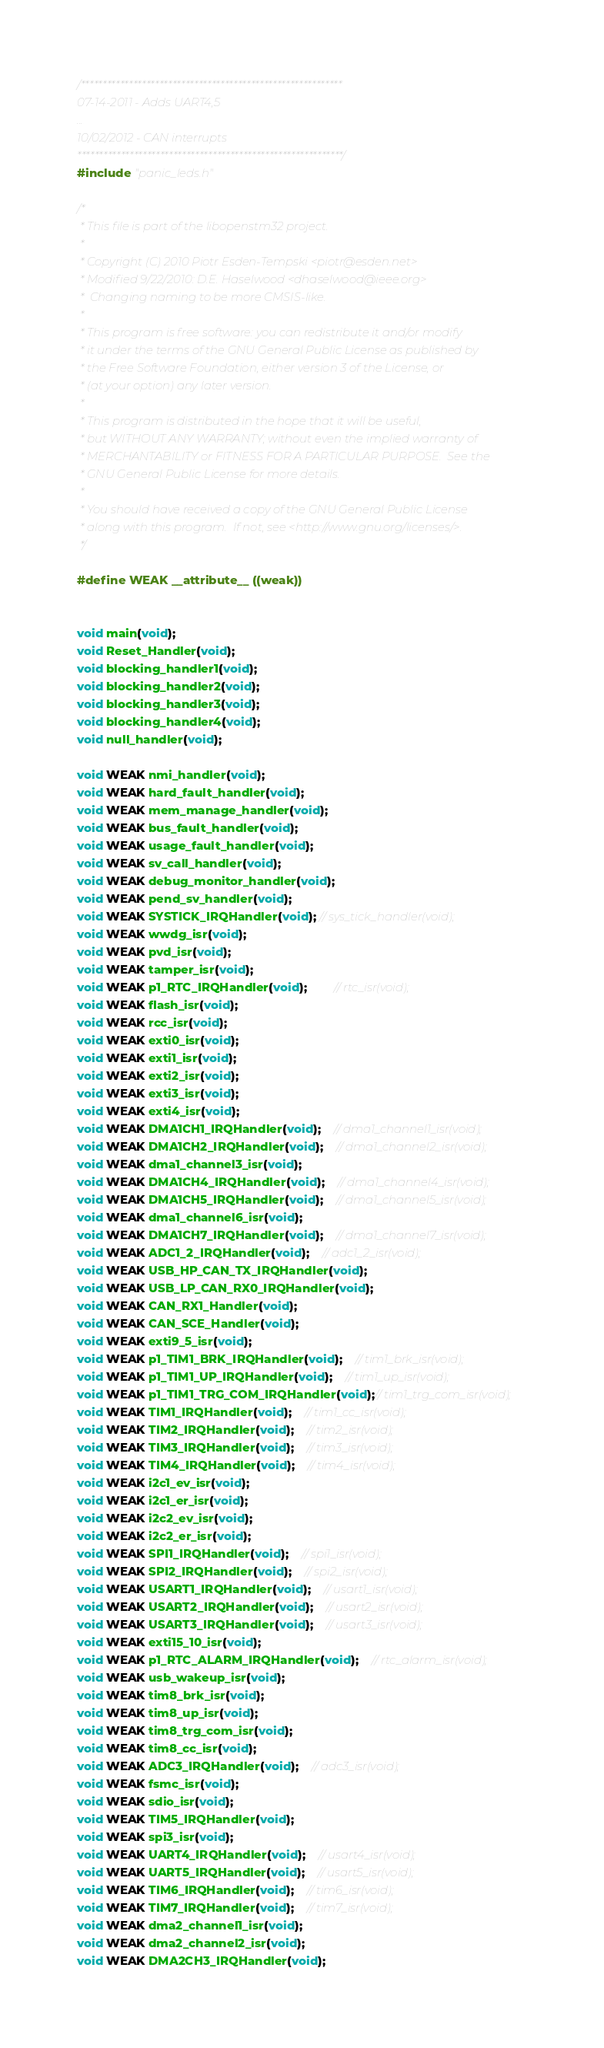Convert code to text. <code><loc_0><loc_0><loc_500><loc_500><_C_>/************************************************************
07-14-2011 - Adds UART4,5
...
10/02/2012 - CAN interrupts
*************************************************************/
#include "panic_leds.h"

/*
 * This file is part of the libopenstm32 project.
 *
 * Copyright (C) 2010 Piotr Esden-Tempski <piotr@esden.net>
 * Modified 9/22/2010: D.E. Haselwood <dhaselwood@ieee.org>
 *  Changing naming to be more CMSIS-like.
 *
 * This program is free software: you can redistribute it and/or modify
 * it under the terms of the GNU General Public License as published by
 * the Free Software Foundation, either version 3 of the License, or
 * (at your option) any later version.
 *
 * This program is distributed in the hope that it will be useful,
 * but WITHOUT ANY WARRANTY; without even the implied warranty of
 * MERCHANTABILITY or FITNESS FOR A PARTICULAR PURPOSE.  See the
 * GNU General Public License for more details.
 *
 * You should have received a copy of the GNU General Public License
 * along with this program.  If not, see <http://www.gnu.org/licenses/>.
 */

#define WEAK __attribute__ ((weak))


void main(void);
void Reset_Handler(void);
void blocking_handler1(void);
void blocking_handler2(void);
void blocking_handler3(void);
void blocking_handler4(void);
void null_handler(void);

void WEAK nmi_handler(void);
void WEAK hard_fault_handler(void);
void WEAK mem_manage_handler(void);
void WEAK bus_fault_handler(void);
void WEAK usage_fault_handler(void);
void WEAK sv_call_handler(void);
void WEAK debug_monitor_handler(void);
void WEAK pend_sv_handler(void);
void WEAK SYSTICK_IRQHandler(void); // sys_tick_handler(void);
void WEAK wwdg_isr(void);
void WEAK pvd_isr(void);
void WEAK tamper_isr(void);
void WEAK p1_RTC_IRQHandler(void);	    // rtc_isr(void);
void WEAK flash_isr(void);
void WEAK rcc_isr(void);
void WEAK exti0_isr(void);
void WEAK exti1_isr(void);
void WEAK exti2_isr(void);
void WEAK exti3_isr(void);
void WEAK exti4_isr(void);
void WEAK DMA1CH1_IRQHandler(void);	// dma1_channel1_isr(void);
void WEAK DMA1CH2_IRQHandler(void); 	// dma1_channel2_isr(void);
void WEAK dma1_channel3_isr(void);
void WEAK DMA1CH4_IRQHandler(void); 	// dma1_channel4_isr(void);
void WEAK DMA1CH5_IRQHandler(void); 	// dma1_channel5_isr(void);
void WEAK dma1_channel6_isr(void);
void WEAK DMA1CH7_IRQHandler(void); 	// dma1_channel7_isr(void);
void WEAK ADC1_2_IRQHandler(void);	// adc1_2_isr(void);
void WEAK USB_HP_CAN_TX_IRQHandler(void);
void WEAK USB_LP_CAN_RX0_IRQHandler(void);
void WEAK CAN_RX1_Handler(void);
void WEAK CAN_SCE_Handler(void);
void WEAK exti9_5_isr(void);
void WEAK p1_TIM1_BRK_IRQHandler(void);	// tim1_brk_isr(void);
void WEAK p1_TIM1_UP_IRQHandler(void);	// tim1_up_isr(void);
void WEAK p1_TIM1_TRG_COM_IRQHandler(void);// tim1_trg_com_isr(void);
void WEAK TIM1_IRQHandler(void);	// tim1_cc_isr(void);
void WEAK TIM2_IRQHandler(void);	// tim2_isr(void);
void WEAK TIM3_IRQHandler(void);	// tim3_isr(void);
void WEAK TIM4_IRQHandler(void);	// tim4_isr(void);
void WEAK i2c1_ev_isr(void);
void WEAK i2c1_er_isr(void);
void WEAK i2c2_ev_isr(void);
void WEAK i2c2_er_isr(void);
void WEAK SPI1_IRQHandler(void);	// spi1_isr(void);
void WEAK SPI2_IRQHandler(void);	// spi2_isr(void);
void WEAK USART1_IRQHandler(void);	// usart1_isr(void);
void WEAK USART2_IRQHandler(void);	// usart2_isr(void);
void WEAK USART3_IRQHandler(void);	// usart3_isr(void);
void WEAK exti15_10_isr(void);
void WEAK p1_RTC_ALARM_IRQHandler(void);	// rtc_alarm_isr(void);
void WEAK usb_wakeup_isr(void);
void WEAK tim8_brk_isr(void);
void WEAK tim8_up_isr(void);
void WEAK tim8_trg_com_isr(void);
void WEAK tim8_cc_isr(void);
void WEAK ADC3_IRQHandler(void);	// adc3_isr(void);
void WEAK fsmc_isr(void);
void WEAK sdio_isr(void);
void WEAK TIM5_IRQHandler(void);
void WEAK spi3_isr(void);
void WEAK UART4_IRQHandler(void);	// usart4_isr(void);
void WEAK UART5_IRQHandler(void);	// usart5_isr(void);
void WEAK TIM6_IRQHandler(void);	// tim6_isr(void);
void WEAK TIM7_IRQHandler(void);	// tim7_isr(void);
void WEAK dma2_channel1_isr(void);
void WEAK dma2_channel2_isr(void);
void WEAK DMA2CH3_IRQHandler(void);</code> 